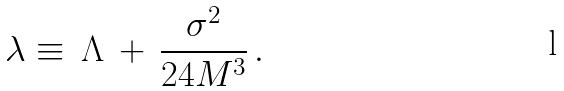Convert formula to latex. <formula><loc_0><loc_0><loc_500><loc_500>\lambda \equiv \, \Lambda \, + \, \frac { \sigma ^ { 2 } } { 2 4 M ^ { 3 } } \, .</formula> 